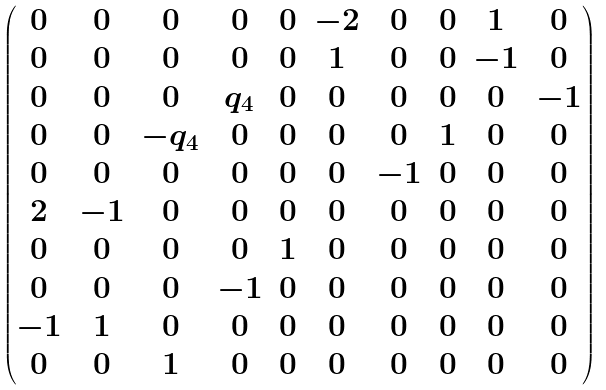<formula> <loc_0><loc_0><loc_500><loc_500>\begin{pmatrix} 0 & 0 & 0 & 0 & 0 & - 2 & 0 & 0 & 1 & 0 \\ 0 & 0 & 0 & 0 & 0 & 1 & 0 & 0 & - 1 & 0 \\ 0 & 0 & 0 & q _ { 4 } & 0 & 0 & 0 & 0 & 0 & - 1 \\ 0 & 0 & - q _ { 4 } & 0 & 0 & 0 & 0 & 1 & 0 & 0 \\ 0 & 0 & 0 & 0 & 0 & 0 & - 1 & 0 & 0 & 0 \\ 2 & - 1 & 0 & 0 & 0 & 0 & 0 & 0 & 0 & 0 \\ 0 & 0 & 0 & 0 & 1 & 0 & 0 & 0 & 0 & 0 \\ 0 & 0 & 0 & - 1 & 0 & 0 & 0 & 0 & 0 & 0 \\ - 1 & 1 & 0 & 0 & 0 & 0 & 0 & 0 & 0 & 0 \\ 0 & 0 & 1 & 0 & 0 & 0 & 0 & 0 & 0 & 0 \end{pmatrix}</formula> 